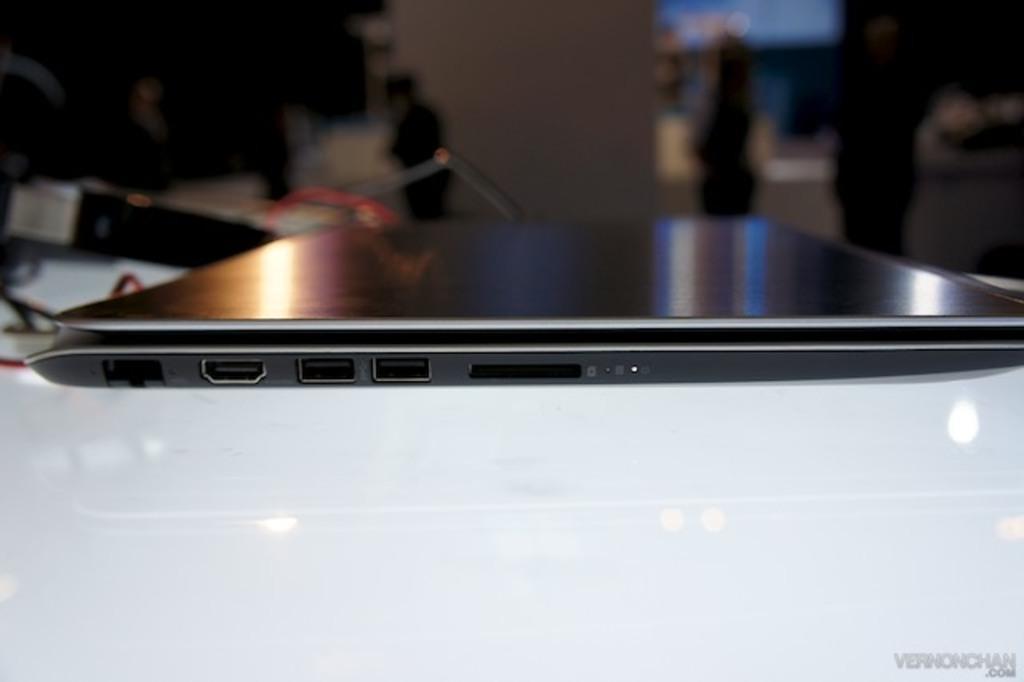In one or two sentences, can you explain what this image depicts? In this image we can see there is a laptop on the white surface. In the background it is blur. 